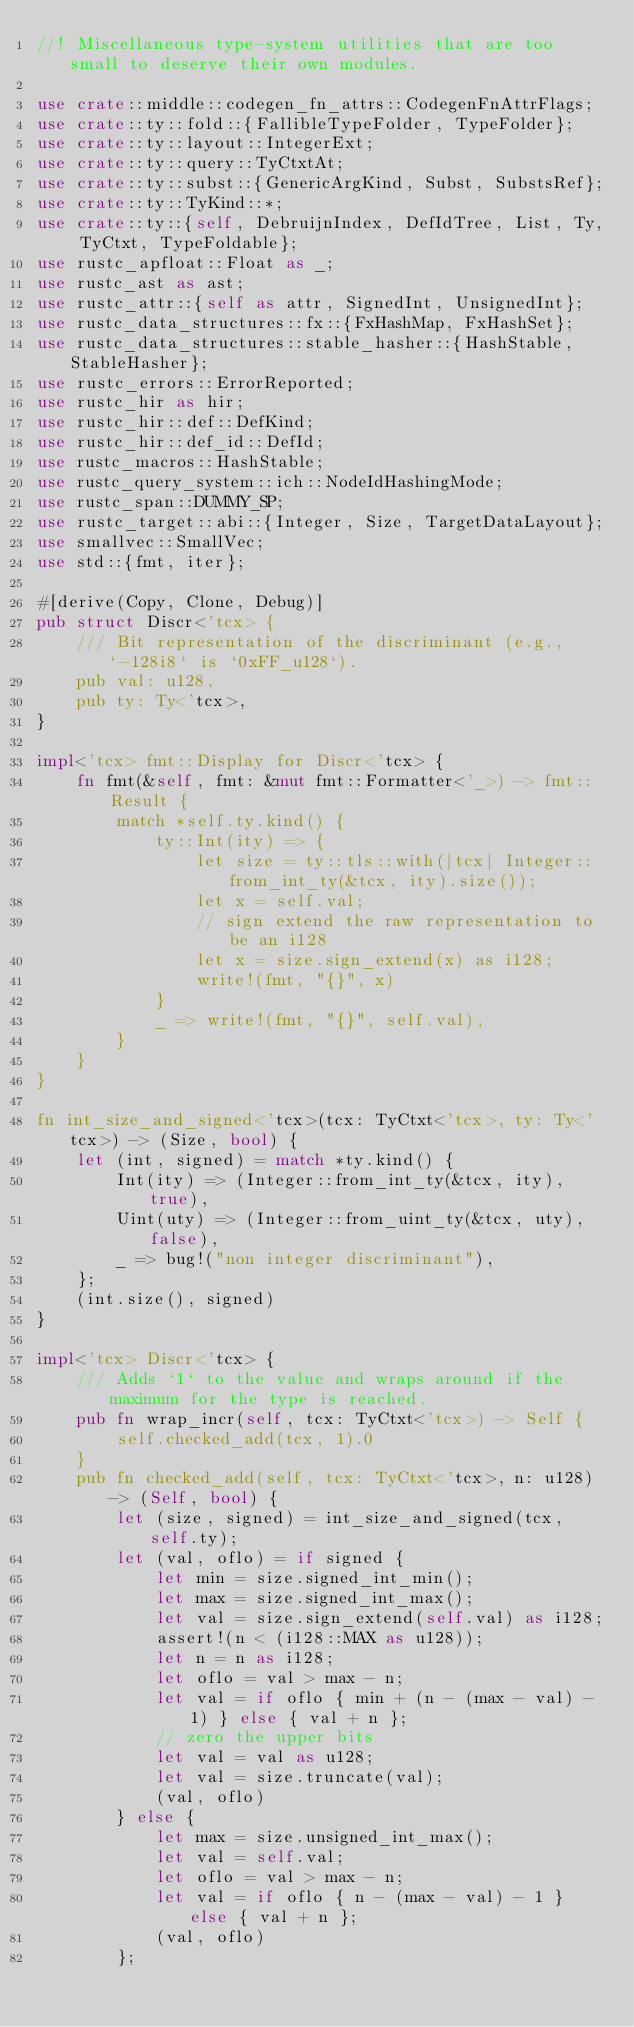<code> <loc_0><loc_0><loc_500><loc_500><_Rust_>//! Miscellaneous type-system utilities that are too small to deserve their own modules.

use crate::middle::codegen_fn_attrs::CodegenFnAttrFlags;
use crate::ty::fold::{FallibleTypeFolder, TypeFolder};
use crate::ty::layout::IntegerExt;
use crate::ty::query::TyCtxtAt;
use crate::ty::subst::{GenericArgKind, Subst, SubstsRef};
use crate::ty::TyKind::*;
use crate::ty::{self, DebruijnIndex, DefIdTree, List, Ty, TyCtxt, TypeFoldable};
use rustc_apfloat::Float as _;
use rustc_ast as ast;
use rustc_attr::{self as attr, SignedInt, UnsignedInt};
use rustc_data_structures::fx::{FxHashMap, FxHashSet};
use rustc_data_structures::stable_hasher::{HashStable, StableHasher};
use rustc_errors::ErrorReported;
use rustc_hir as hir;
use rustc_hir::def::DefKind;
use rustc_hir::def_id::DefId;
use rustc_macros::HashStable;
use rustc_query_system::ich::NodeIdHashingMode;
use rustc_span::DUMMY_SP;
use rustc_target::abi::{Integer, Size, TargetDataLayout};
use smallvec::SmallVec;
use std::{fmt, iter};

#[derive(Copy, Clone, Debug)]
pub struct Discr<'tcx> {
    /// Bit representation of the discriminant (e.g., `-128i8` is `0xFF_u128`).
    pub val: u128,
    pub ty: Ty<'tcx>,
}

impl<'tcx> fmt::Display for Discr<'tcx> {
    fn fmt(&self, fmt: &mut fmt::Formatter<'_>) -> fmt::Result {
        match *self.ty.kind() {
            ty::Int(ity) => {
                let size = ty::tls::with(|tcx| Integer::from_int_ty(&tcx, ity).size());
                let x = self.val;
                // sign extend the raw representation to be an i128
                let x = size.sign_extend(x) as i128;
                write!(fmt, "{}", x)
            }
            _ => write!(fmt, "{}", self.val),
        }
    }
}

fn int_size_and_signed<'tcx>(tcx: TyCtxt<'tcx>, ty: Ty<'tcx>) -> (Size, bool) {
    let (int, signed) = match *ty.kind() {
        Int(ity) => (Integer::from_int_ty(&tcx, ity), true),
        Uint(uty) => (Integer::from_uint_ty(&tcx, uty), false),
        _ => bug!("non integer discriminant"),
    };
    (int.size(), signed)
}

impl<'tcx> Discr<'tcx> {
    /// Adds `1` to the value and wraps around if the maximum for the type is reached.
    pub fn wrap_incr(self, tcx: TyCtxt<'tcx>) -> Self {
        self.checked_add(tcx, 1).0
    }
    pub fn checked_add(self, tcx: TyCtxt<'tcx>, n: u128) -> (Self, bool) {
        let (size, signed) = int_size_and_signed(tcx, self.ty);
        let (val, oflo) = if signed {
            let min = size.signed_int_min();
            let max = size.signed_int_max();
            let val = size.sign_extend(self.val) as i128;
            assert!(n < (i128::MAX as u128));
            let n = n as i128;
            let oflo = val > max - n;
            let val = if oflo { min + (n - (max - val) - 1) } else { val + n };
            // zero the upper bits
            let val = val as u128;
            let val = size.truncate(val);
            (val, oflo)
        } else {
            let max = size.unsigned_int_max();
            let val = self.val;
            let oflo = val > max - n;
            let val = if oflo { n - (max - val) - 1 } else { val + n };
            (val, oflo)
        };</code> 